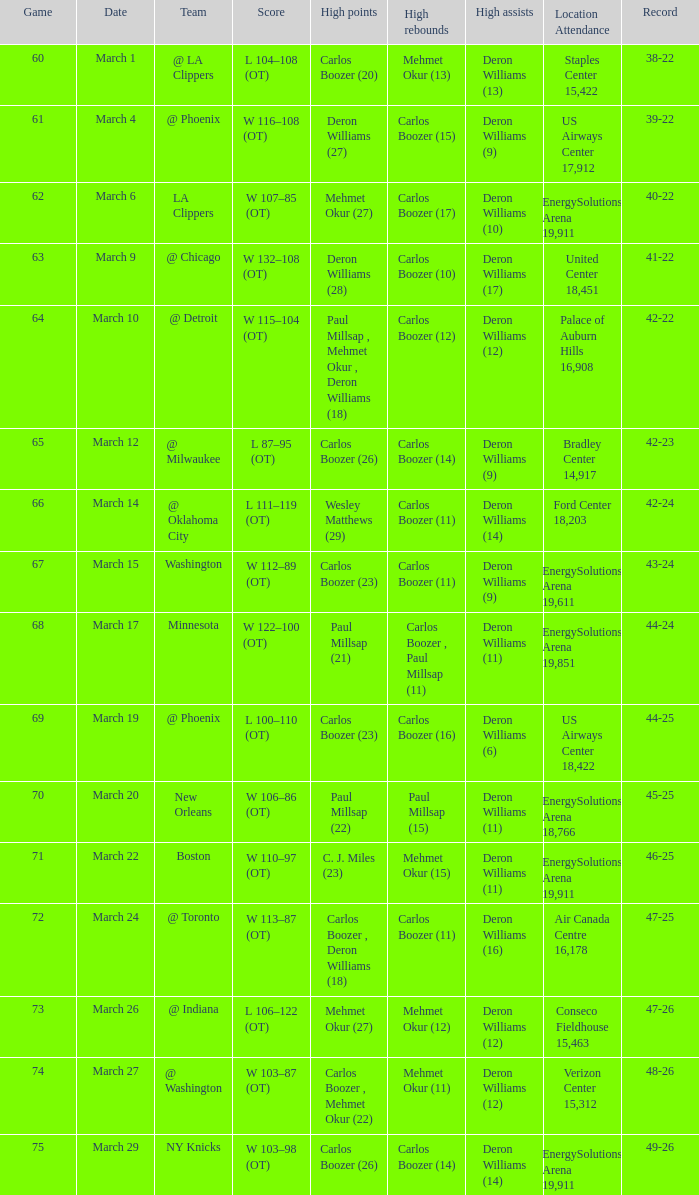Where was the March 24 game played? Air Canada Centre 16,178. I'm looking to parse the entire table for insights. Could you assist me with that? {'header': ['Game', 'Date', 'Team', 'Score', 'High points', 'High rebounds', 'High assists', 'Location Attendance', 'Record'], 'rows': [['60', 'March 1', '@ LA Clippers', 'L 104–108 (OT)', 'Carlos Boozer (20)', 'Mehmet Okur (13)', 'Deron Williams (13)', 'Staples Center 15,422', '38-22'], ['61', 'March 4', '@ Phoenix', 'W 116–108 (OT)', 'Deron Williams (27)', 'Carlos Boozer (15)', 'Deron Williams (9)', 'US Airways Center 17,912', '39-22'], ['62', 'March 6', 'LA Clippers', 'W 107–85 (OT)', 'Mehmet Okur (27)', 'Carlos Boozer (17)', 'Deron Williams (10)', 'EnergySolutions Arena 19,911', '40-22'], ['63', 'March 9', '@ Chicago', 'W 132–108 (OT)', 'Deron Williams (28)', 'Carlos Boozer (10)', 'Deron Williams (17)', 'United Center 18,451', '41-22'], ['64', 'March 10', '@ Detroit', 'W 115–104 (OT)', 'Paul Millsap , Mehmet Okur , Deron Williams (18)', 'Carlos Boozer (12)', 'Deron Williams (12)', 'Palace of Auburn Hills 16,908', '42-22'], ['65', 'March 12', '@ Milwaukee', 'L 87–95 (OT)', 'Carlos Boozer (26)', 'Carlos Boozer (14)', 'Deron Williams (9)', 'Bradley Center 14,917', '42-23'], ['66', 'March 14', '@ Oklahoma City', 'L 111–119 (OT)', 'Wesley Matthews (29)', 'Carlos Boozer (11)', 'Deron Williams (14)', 'Ford Center 18,203', '42-24'], ['67', 'March 15', 'Washington', 'W 112–89 (OT)', 'Carlos Boozer (23)', 'Carlos Boozer (11)', 'Deron Williams (9)', 'EnergySolutions Arena 19,611', '43-24'], ['68', 'March 17', 'Minnesota', 'W 122–100 (OT)', 'Paul Millsap (21)', 'Carlos Boozer , Paul Millsap (11)', 'Deron Williams (11)', 'EnergySolutions Arena 19,851', '44-24'], ['69', 'March 19', '@ Phoenix', 'L 100–110 (OT)', 'Carlos Boozer (23)', 'Carlos Boozer (16)', 'Deron Williams (6)', 'US Airways Center 18,422', '44-25'], ['70', 'March 20', 'New Orleans', 'W 106–86 (OT)', 'Paul Millsap (22)', 'Paul Millsap (15)', 'Deron Williams (11)', 'EnergySolutions Arena 18,766', '45-25'], ['71', 'March 22', 'Boston', 'W 110–97 (OT)', 'C. J. Miles (23)', 'Mehmet Okur (15)', 'Deron Williams (11)', 'EnergySolutions Arena 19,911', '46-25'], ['72', 'March 24', '@ Toronto', 'W 113–87 (OT)', 'Carlos Boozer , Deron Williams (18)', 'Carlos Boozer (11)', 'Deron Williams (16)', 'Air Canada Centre 16,178', '47-25'], ['73', 'March 26', '@ Indiana', 'L 106–122 (OT)', 'Mehmet Okur (27)', 'Mehmet Okur (12)', 'Deron Williams (12)', 'Conseco Fieldhouse 15,463', '47-26'], ['74', 'March 27', '@ Washington', 'W 103–87 (OT)', 'Carlos Boozer , Mehmet Okur (22)', 'Mehmet Okur (11)', 'Deron Williams (12)', 'Verizon Center 15,312', '48-26'], ['75', 'March 29', 'NY Knicks', 'W 103–98 (OT)', 'Carlos Boozer (26)', 'Carlos Boozer (14)', 'Deron Williams (14)', 'EnergySolutions Arena 19,911', '49-26']]} 